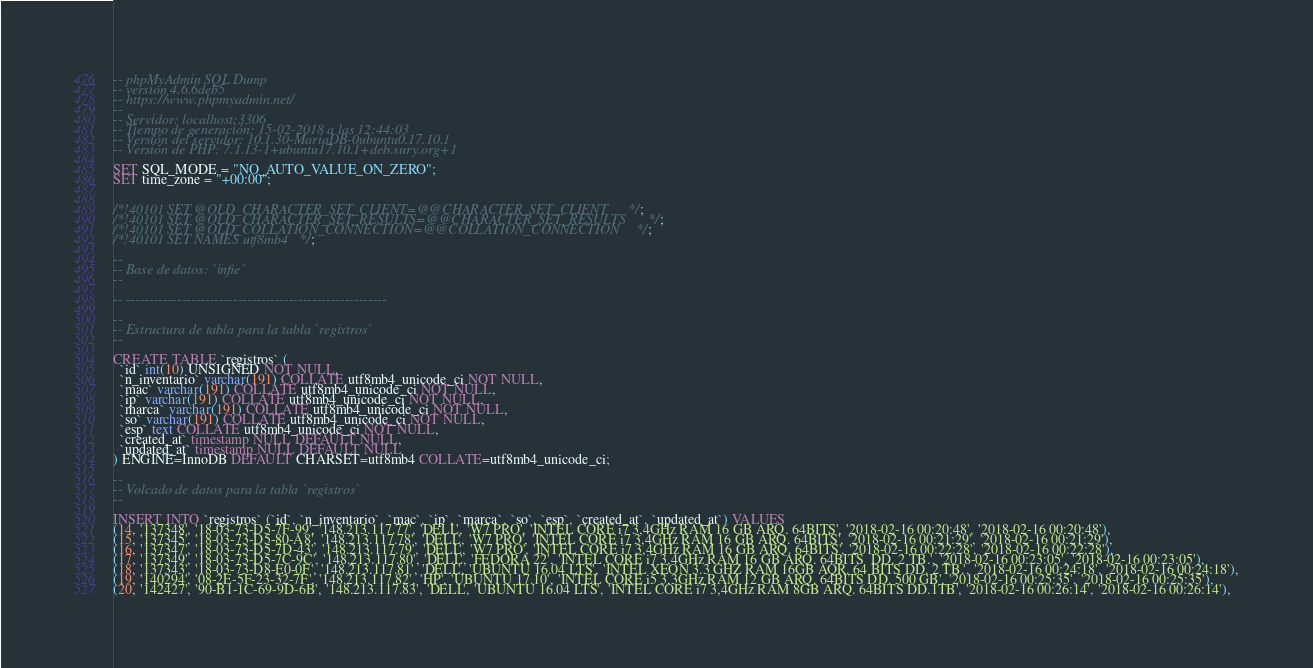<code> <loc_0><loc_0><loc_500><loc_500><_SQL_>-- phpMyAdmin SQL Dump
-- version 4.6.6deb5
-- https://www.phpmyadmin.net/
--
-- Servidor: localhost:3306
-- Tiempo de generación: 15-02-2018 a las 12:44:03
-- Versión del servidor: 10.1.30-MariaDB-0ubuntu0.17.10.1
-- Versión de PHP: 7.1.13-1+ubuntu17.10.1+deb.sury.org+1

SET SQL_MODE = "NO_AUTO_VALUE_ON_ZERO";
SET time_zone = "+00:00";


/*!40101 SET @OLD_CHARACTER_SET_CLIENT=@@CHARACTER_SET_CLIENT */;
/*!40101 SET @OLD_CHARACTER_SET_RESULTS=@@CHARACTER_SET_RESULTS */;
/*!40101 SET @OLD_COLLATION_CONNECTION=@@COLLATION_CONNECTION */;
/*!40101 SET NAMES utf8mb4 */;

--
-- Base de datos: `infie`
--

-- --------------------------------------------------------

--
-- Estructura de tabla para la tabla `registros`
--

CREATE TABLE `registros` (
  `id` int(10) UNSIGNED NOT NULL,
  `n_inventario` varchar(191) COLLATE utf8mb4_unicode_ci NOT NULL,
  `mac` varchar(191) COLLATE utf8mb4_unicode_ci NOT NULL,
  `ip` varchar(191) COLLATE utf8mb4_unicode_ci NOT NULL,
  `marca` varchar(191) COLLATE utf8mb4_unicode_ci NOT NULL,
  `so` varchar(191) COLLATE utf8mb4_unicode_ci NOT NULL,
  `esp` text COLLATE utf8mb4_unicode_ci NOT NULL,
  `created_at` timestamp NULL DEFAULT NULL,
  `updated_at` timestamp NULL DEFAULT NULL
) ENGINE=InnoDB DEFAULT CHARSET=utf8mb4 COLLATE=utf8mb4_unicode_ci;

--
-- Volcado de datos para la tabla `registros`
--

INSERT INTO `registros` (`id`, `n_inventario`, `mac`, `ip`, `marca`, `so`, `esp`, `created_at`, `updated_at`) VALUES
(14, '137348', '18-03-73-D5-7F-99', '148.213.117.77', 'DELL', 'W7 PRO', 'INTEL CORE i7 3,4GHz RAM 16 GB ARQ. 64BITS', '2018-02-16 00:20:48', '2018-02-16 00:20:48'),
(15, '137345', '18-03-73-D5-80-A8', '148.213.117.78', 'DELL', 'W7 PRO', 'INTEL CORE i7 3,4GHz RAM 16 GB ARQ. 64BITS', '2018-02-16 00:21:29', '2018-02-16 00:21:29'),
(16, '137347', '18-03-73-D5-7D-43', '148.213.117.79', 'DELL', 'W7 PRO', 'INTEL CORE i7 3,4GHz RAM 16 GB ARQ. 64BITS', '2018-02-16 00:22:28', '2018-02-16 00:22:28'),
(17, '137349', '18-03-73-D5-7C-9C', '148.213.117.80', 'DELL', 'FEDORA 22', 'INTEL CORE i7 3,4GHz RAM 16 GB ARQ. 64BITS  DD. 2 TB.', '2018-02-16 00:23:05', '2018-02-16 00:23:05'),
(18, '137343', '18-03-73-D8-E0-0F', '148.213.117.81', 'DELL', 'UBUNTU 16.04 LTS', 'INTEL XEON 3.3 GHZ RAM 16GB AQR. 64 BITS DD. 2 TB.', '2018-02-16 00:24:18', '2018-02-16 00:24:18'),
(19, '140294', '08-2E-5F-23-32-7F', '148.213.117.82', 'HP', 'UBUNTU 17.10', 'INTEL CORE i5 3,3GHz RAM 12 GB ARQ. 64BITS DD. 500 GB', '2018-02-16 00:25:35', '2018-02-16 00:25:35'),
(20, '142427', '90-B1-1C-69-9D-6B', '148.213.117.83', 'DELL', 'UBUNTU 16.04 LTS', 'INTEL CORE i7 3,4GHz RAM 8GB ARQ. 64BITS DD.1TB', '2018-02-16 00:26:14', '2018-02-16 00:26:14'),</code> 